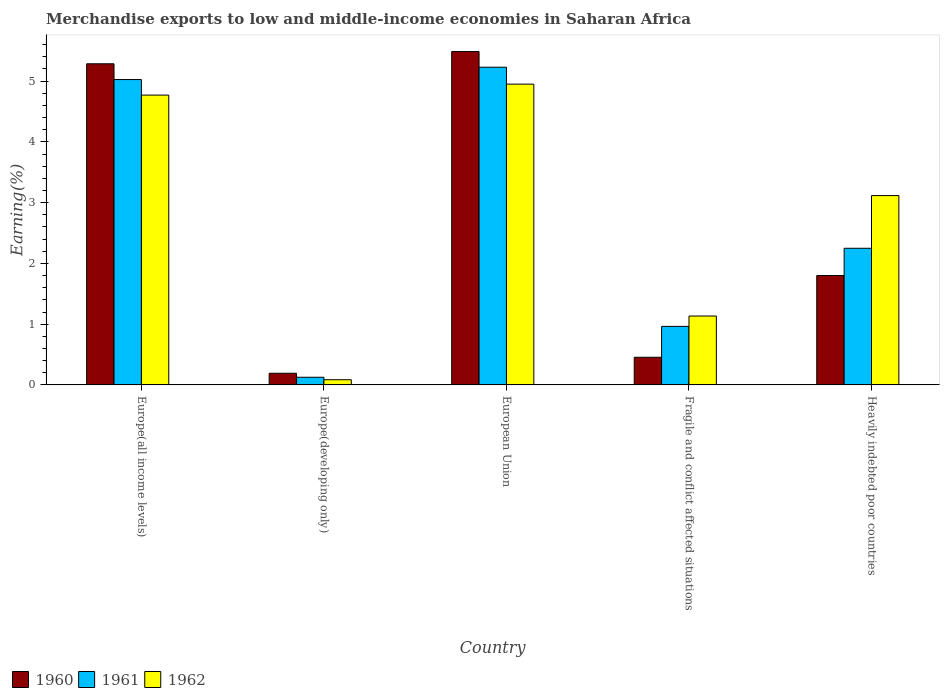How many different coloured bars are there?
Ensure brevity in your answer.  3. Are the number of bars on each tick of the X-axis equal?
Your response must be concise. Yes. How many bars are there on the 2nd tick from the left?
Offer a very short reply. 3. How many bars are there on the 3rd tick from the right?
Your answer should be very brief. 3. What is the label of the 1st group of bars from the left?
Make the answer very short. Europe(all income levels). In how many cases, is the number of bars for a given country not equal to the number of legend labels?
Your answer should be compact. 0. What is the percentage of amount earned from merchandise exports in 1962 in Heavily indebted poor countries?
Make the answer very short. 3.12. Across all countries, what is the maximum percentage of amount earned from merchandise exports in 1960?
Give a very brief answer. 5.49. Across all countries, what is the minimum percentage of amount earned from merchandise exports in 1962?
Give a very brief answer. 0.09. In which country was the percentage of amount earned from merchandise exports in 1961 maximum?
Make the answer very short. European Union. In which country was the percentage of amount earned from merchandise exports in 1961 minimum?
Keep it short and to the point. Europe(developing only). What is the total percentage of amount earned from merchandise exports in 1961 in the graph?
Give a very brief answer. 13.59. What is the difference between the percentage of amount earned from merchandise exports in 1960 in European Union and that in Heavily indebted poor countries?
Ensure brevity in your answer.  3.69. What is the difference between the percentage of amount earned from merchandise exports in 1960 in Europe(developing only) and the percentage of amount earned from merchandise exports in 1961 in Heavily indebted poor countries?
Ensure brevity in your answer.  -2.06. What is the average percentage of amount earned from merchandise exports in 1962 per country?
Your answer should be compact. 2.81. What is the difference between the percentage of amount earned from merchandise exports of/in 1961 and percentage of amount earned from merchandise exports of/in 1960 in European Union?
Your response must be concise. -0.26. What is the ratio of the percentage of amount earned from merchandise exports in 1961 in Europe(developing only) to that in European Union?
Ensure brevity in your answer.  0.02. Is the percentage of amount earned from merchandise exports in 1961 in Europe(developing only) less than that in Heavily indebted poor countries?
Offer a very short reply. Yes. What is the difference between the highest and the second highest percentage of amount earned from merchandise exports in 1962?
Give a very brief answer. -1.83. What is the difference between the highest and the lowest percentage of amount earned from merchandise exports in 1961?
Make the answer very short. 5.1. Is the sum of the percentage of amount earned from merchandise exports in 1962 in Fragile and conflict affected situations and Heavily indebted poor countries greater than the maximum percentage of amount earned from merchandise exports in 1960 across all countries?
Provide a succinct answer. No. Is it the case that in every country, the sum of the percentage of amount earned from merchandise exports in 1962 and percentage of amount earned from merchandise exports in 1960 is greater than the percentage of amount earned from merchandise exports in 1961?
Keep it short and to the point. Yes. How many bars are there?
Offer a very short reply. 15. Are all the bars in the graph horizontal?
Keep it short and to the point. No. Are the values on the major ticks of Y-axis written in scientific E-notation?
Offer a terse response. No. Does the graph contain grids?
Provide a short and direct response. No. How many legend labels are there?
Provide a short and direct response. 3. How are the legend labels stacked?
Your response must be concise. Horizontal. What is the title of the graph?
Make the answer very short. Merchandise exports to low and middle-income economies in Saharan Africa. What is the label or title of the X-axis?
Offer a very short reply. Country. What is the label or title of the Y-axis?
Offer a very short reply. Earning(%). What is the Earning(%) of 1960 in Europe(all income levels)?
Keep it short and to the point. 5.29. What is the Earning(%) of 1961 in Europe(all income levels)?
Make the answer very short. 5.03. What is the Earning(%) of 1962 in Europe(all income levels)?
Offer a terse response. 4.77. What is the Earning(%) in 1960 in Europe(developing only)?
Provide a succinct answer. 0.19. What is the Earning(%) of 1961 in Europe(developing only)?
Your response must be concise. 0.13. What is the Earning(%) in 1962 in Europe(developing only)?
Give a very brief answer. 0.09. What is the Earning(%) of 1960 in European Union?
Offer a terse response. 5.49. What is the Earning(%) in 1961 in European Union?
Your response must be concise. 5.23. What is the Earning(%) of 1962 in European Union?
Your answer should be compact. 4.95. What is the Earning(%) in 1960 in Fragile and conflict affected situations?
Your answer should be compact. 0.45. What is the Earning(%) in 1961 in Fragile and conflict affected situations?
Your answer should be compact. 0.96. What is the Earning(%) in 1962 in Fragile and conflict affected situations?
Your response must be concise. 1.13. What is the Earning(%) in 1960 in Heavily indebted poor countries?
Offer a terse response. 1.8. What is the Earning(%) in 1961 in Heavily indebted poor countries?
Provide a succinct answer. 2.25. What is the Earning(%) of 1962 in Heavily indebted poor countries?
Your response must be concise. 3.12. Across all countries, what is the maximum Earning(%) in 1960?
Offer a very short reply. 5.49. Across all countries, what is the maximum Earning(%) of 1961?
Offer a terse response. 5.23. Across all countries, what is the maximum Earning(%) of 1962?
Give a very brief answer. 4.95. Across all countries, what is the minimum Earning(%) of 1960?
Provide a succinct answer. 0.19. Across all countries, what is the minimum Earning(%) of 1961?
Provide a succinct answer. 0.13. Across all countries, what is the minimum Earning(%) of 1962?
Your response must be concise. 0.09. What is the total Earning(%) in 1960 in the graph?
Give a very brief answer. 13.22. What is the total Earning(%) of 1961 in the graph?
Offer a very short reply. 13.59. What is the total Earning(%) of 1962 in the graph?
Make the answer very short. 14.06. What is the difference between the Earning(%) in 1960 in Europe(all income levels) and that in Europe(developing only)?
Your response must be concise. 5.09. What is the difference between the Earning(%) of 1961 in Europe(all income levels) and that in Europe(developing only)?
Keep it short and to the point. 4.9. What is the difference between the Earning(%) in 1962 in Europe(all income levels) and that in Europe(developing only)?
Ensure brevity in your answer.  4.68. What is the difference between the Earning(%) of 1960 in Europe(all income levels) and that in European Union?
Provide a short and direct response. -0.2. What is the difference between the Earning(%) in 1961 in Europe(all income levels) and that in European Union?
Keep it short and to the point. -0.2. What is the difference between the Earning(%) in 1962 in Europe(all income levels) and that in European Union?
Make the answer very short. -0.18. What is the difference between the Earning(%) of 1960 in Europe(all income levels) and that in Fragile and conflict affected situations?
Keep it short and to the point. 4.83. What is the difference between the Earning(%) of 1961 in Europe(all income levels) and that in Fragile and conflict affected situations?
Give a very brief answer. 4.06. What is the difference between the Earning(%) of 1962 in Europe(all income levels) and that in Fragile and conflict affected situations?
Your answer should be very brief. 3.64. What is the difference between the Earning(%) of 1960 in Europe(all income levels) and that in Heavily indebted poor countries?
Your response must be concise. 3.48. What is the difference between the Earning(%) in 1961 in Europe(all income levels) and that in Heavily indebted poor countries?
Provide a succinct answer. 2.78. What is the difference between the Earning(%) in 1962 in Europe(all income levels) and that in Heavily indebted poor countries?
Ensure brevity in your answer.  1.65. What is the difference between the Earning(%) of 1960 in Europe(developing only) and that in European Union?
Your response must be concise. -5.29. What is the difference between the Earning(%) of 1961 in Europe(developing only) and that in European Union?
Give a very brief answer. -5.1. What is the difference between the Earning(%) in 1962 in Europe(developing only) and that in European Union?
Provide a succinct answer. -4.87. What is the difference between the Earning(%) of 1960 in Europe(developing only) and that in Fragile and conflict affected situations?
Your response must be concise. -0.26. What is the difference between the Earning(%) of 1961 in Europe(developing only) and that in Fragile and conflict affected situations?
Provide a short and direct response. -0.84. What is the difference between the Earning(%) in 1962 in Europe(developing only) and that in Fragile and conflict affected situations?
Ensure brevity in your answer.  -1.05. What is the difference between the Earning(%) of 1960 in Europe(developing only) and that in Heavily indebted poor countries?
Make the answer very short. -1.61. What is the difference between the Earning(%) in 1961 in Europe(developing only) and that in Heavily indebted poor countries?
Keep it short and to the point. -2.12. What is the difference between the Earning(%) in 1962 in Europe(developing only) and that in Heavily indebted poor countries?
Give a very brief answer. -3.03. What is the difference between the Earning(%) in 1960 in European Union and that in Fragile and conflict affected situations?
Make the answer very short. 5.03. What is the difference between the Earning(%) in 1961 in European Union and that in Fragile and conflict affected situations?
Offer a terse response. 4.27. What is the difference between the Earning(%) in 1962 in European Union and that in Fragile and conflict affected situations?
Your response must be concise. 3.82. What is the difference between the Earning(%) of 1960 in European Union and that in Heavily indebted poor countries?
Provide a short and direct response. 3.69. What is the difference between the Earning(%) of 1961 in European Union and that in Heavily indebted poor countries?
Ensure brevity in your answer.  2.98. What is the difference between the Earning(%) in 1962 in European Union and that in Heavily indebted poor countries?
Offer a very short reply. 1.83. What is the difference between the Earning(%) of 1960 in Fragile and conflict affected situations and that in Heavily indebted poor countries?
Offer a terse response. -1.35. What is the difference between the Earning(%) in 1961 in Fragile and conflict affected situations and that in Heavily indebted poor countries?
Make the answer very short. -1.29. What is the difference between the Earning(%) of 1962 in Fragile and conflict affected situations and that in Heavily indebted poor countries?
Provide a succinct answer. -1.98. What is the difference between the Earning(%) in 1960 in Europe(all income levels) and the Earning(%) in 1961 in Europe(developing only)?
Your answer should be very brief. 5.16. What is the difference between the Earning(%) of 1960 in Europe(all income levels) and the Earning(%) of 1962 in Europe(developing only)?
Offer a terse response. 5.2. What is the difference between the Earning(%) of 1961 in Europe(all income levels) and the Earning(%) of 1962 in Europe(developing only)?
Offer a terse response. 4.94. What is the difference between the Earning(%) of 1960 in Europe(all income levels) and the Earning(%) of 1961 in European Union?
Your answer should be very brief. 0.06. What is the difference between the Earning(%) in 1960 in Europe(all income levels) and the Earning(%) in 1962 in European Union?
Provide a short and direct response. 0.33. What is the difference between the Earning(%) of 1961 in Europe(all income levels) and the Earning(%) of 1962 in European Union?
Ensure brevity in your answer.  0.08. What is the difference between the Earning(%) of 1960 in Europe(all income levels) and the Earning(%) of 1961 in Fragile and conflict affected situations?
Your response must be concise. 4.32. What is the difference between the Earning(%) in 1960 in Europe(all income levels) and the Earning(%) in 1962 in Fragile and conflict affected situations?
Keep it short and to the point. 4.15. What is the difference between the Earning(%) in 1961 in Europe(all income levels) and the Earning(%) in 1962 in Fragile and conflict affected situations?
Your answer should be compact. 3.89. What is the difference between the Earning(%) in 1960 in Europe(all income levels) and the Earning(%) in 1961 in Heavily indebted poor countries?
Your response must be concise. 3.04. What is the difference between the Earning(%) of 1960 in Europe(all income levels) and the Earning(%) of 1962 in Heavily indebted poor countries?
Provide a succinct answer. 2.17. What is the difference between the Earning(%) in 1961 in Europe(all income levels) and the Earning(%) in 1962 in Heavily indebted poor countries?
Offer a very short reply. 1.91. What is the difference between the Earning(%) in 1960 in Europe(developing only) and the Earning(%) in 1961 in European Union?
Provide a short and direct response. -5.04. What is the difference between the Earning(%) in 1960 in Europe(developing only) and the Earning(%) in 1962 in European Union?
Provide a succinct answer. -4.76. What is the difference between the Earning(%) in 1961 in Europe(developing only) and the Earning(%) in 1962 in European Union?
Make the answer very short. -4.82. What is the difference between the Earning(%) in 1960 in Europe(developing only) and the Earning(%) in 1961 in Fragile and conflict affected situations?
Your response must be concise. -0.77. What is the difference between the Earning(%) of 1960 in Europe(developing only) and the Earning(%) of 1962 in Fragile and conflict affected situations?
Keep it short and to the point. -0.94. What is the difference between the Earning(%) in 1961 in Europe(developing only) and the Earning(%) in 1962 in Fragile and conflict affected situations?
Provide a succinct answer. -1.01. What is the difference between the Earning(%) in 1960 in Europe(developing only) and the Earning(%) in 1961 in Heavily indebted poor countries?
Offer a terse response. -2.06. What is the difference between the Earning(%) of 1960 in Europe(developing only) and the Earning(%) of 1962 in Heavily indebted poor countries?
Ensure brevity in your answer.  -2.92. What is the difference between the Earning(%) in 1961 in Europe(developing only) and the Earning(%) in 1962 in Heavily indebted poor countries?
Provide a succinct answer. -2.99. What is the difference between the Earning(%) in 1960 in European Union and the Earning(%) in 1961 in Fragile and conflict affected situations?
Provide a succinct answer. 4.52. What is the difference between the Earning(%) in 1960 in European Union and the Earning(%) in 1962 in Fragile and conflict affected situations?
Give a very brief answer. 4.35. What is the difference between the Earning(%) of 1961 in European Union and the Earning(%) of 1962 in Fragile and conflict affected situations?
Offer a very short reply. 4.1. What is the difference between the Earning(%) of 1960 in European Union and the Earning(%) of 1961 in Heavily indebted poor countries?
Keep it short and to the point. 3.24. What is the difference between the Earning(%) in 1960 in European Union and the Earning(%) in 1962 in Heavily indebted poor countries?
Make the answer very short. 2.37. What is the difference between the Earning(%) in 1961 in European Union and the Earning(%) in 1962 in Heavily indebted poor countries?
Ensure brevity in your answer.  2.11. What is the difference between the Earning(%) of 1960 in Fragile and conflict affected situations and the Earning(%) of 1961 in Heavily indebted poor countries?
Make the answer very short. -1.79. What is the difference between the Earning(%) of 1960 in Fragile and conflict affected situations and the Earning(%) of 1962 in Heavily indebted poor countries?
Offer a very short reply. -2.66. What is the difference between the Earning(%) in 1961 in Fragile and conflict affected situations and the Earning(%) in 1962 in Heavily indebted poor countries?
Give a very brief answer. -2.15. What is the average Earning(%) in 1960 per country?
Make the answer very short. 2.64. What is the average Earning(%) in 1961 per country?
Give a very brief answer. 2.72. What is the average Earning(%) of 1962 per country?
Offer a very short reply. 2.81. What is the difference between the Earning(%) of 1960 and Earning(%) of 1961 in Europe(all income levels)?
Your response must be concise. 0.26. What is the difference between the Earning(%) in 1960 and Earning(%) in 1962 in Europe(all income levels)?
Offer a terse response. 0.52. What is the difference between the Earning(%) of 1961 and Earning(%) of 1962 in Europe(all income levels)?
Offer a very short reply. 0.26. What is the difference between the Earning(%) in 1960 and Earning(%) in 1961 in Europe(developing only)?
Ensure brevity in your answer.  0.07. What is the difference between the Earning(%) in 1960 and Earning(%) in 1962 in Europe(developing only)?
Your answer should be very brief. 0.11. What is the difference between the Earning(%) in 1961 and Earning(%) in 1962 in Europe(developing only)?
Make the answer very short. 0.04. What is the difference between the Earning(%) in 1960 and Earning(%) in 1961 in European Union?
Make the answer very short. 0.26. What is the difference between the Earning(%) of 1960 and Earning(%) of 1962 in European Union?
Keep it short and to the point. 0.54. What is the difference between the Earning(%) of 1961 and Earning(%) of 1962 in European Union?
Keep it short and to the point. 0.28. What is the difference between the Earning(%) in 1960 and Earning(%) in 1961 in Fragile and conflict affected situations?
Keep it short and to the point. -0.51. What is the difference between the Earning(%) of 1960 and Earning(%) of 1962 in Fragile and conflict affected situations?
Offer a terse response. -0.68. What is the difference between the Earning(%) of 1961 and Earning(%) of 1962 in Fragile and conflict affected situations?
Provide a short and direct response. -0.17. What is the difference between the Earning(%) in 1960 and Earning(%) in 1961 in Heavily indebted poor countries?
Make the answer very short. -0.45. What is the difference between the Earning(%) of 1960 and Earning(%) of 1962 in Heavily indebted poor countries?
Make the answer very short. -1.32. What is the difference between the Earning(%) of 1961 and Earning(%) of 1962 in Heavily indebted poor countries?
Offer a very short reply. -0.87. What is the ratio of the Earning(%) of 1960 in Europe(all income levels) to that in Europe(developing only)?
Offer a very short reply. 27.54. What is the ratio of the Earning(%) of 1961 in Europe(all income levels) to that in Europe(developing only)?
Ensure brevity in your answer.  39.9. What is the ratio of the Earning(%) in 1962 in Europe(all income levels) to that in Europe(developing only)?
Ensure brevity in your answer.  55.85. What is the ratio of the Earning(%) in 1960 in Europe(all income levels) to that in European Union?
Ensure brevity in your answer.  0.96. What is the ratio of the Earning(%) in 1961 in Europe(all income levels) to that in European Union?
Make the answer very short. 0.96. What is the ratio of the Earning(%) of 1962 in Europe(all income levels) to that in European Union?
Provide a short and direct response. 0.96. What is the ratio of the Earning(%) in 1960 in Europe(all income levels) to that in Fragile and conflict affected situations?
Make the answer very short. 11.62. What is the ratio of the Earning(%) in 1961 in Europe(all income levels) to that in Fragile and conflict affected situations?
Make the answer very short. 5.22. What is the ratio of the Earning(%) in 1962 in Europe(all income levels) to that in Fragile and conflict affected situations?
Ensure brevity in your answer.  4.21. What is the ratio of the Earning(%) of 1960 in Europe(all income levels) to that in Heavily indebted poor countries?
Offer a very short reply. 2.94. What is the ratio of the Earning(%) of 1961 in Europe(all income levels) to that in Heavily indebted poor countries?
Give a very brief answer. 2.23. What is the ratio of the Earning(%) of 1962 in Europe(all income levels) to that in Heavily indebted poor countries?
Make the answer very short. 1.53. What is the ratio of the Earning(%) in 1960 in Europe(developing only) to that in European Union?
Offer a very short reply. 0.04. What is the ratio of the Earning(%) in 1961 in Europe(developing only) to that in European Union?
Your answer should be very brief. 0.02. What is the ratio of the Earning(%) in 1962 in Europe(developing only) to that in European Union?
Give a very brief answer. 0.02. What is the ratio of the Earning(%) of 1960 in Europe(developing only) to that in Fragile and conflict affected situations?
Offer a very short reply. 0.42. What is the ratio of the Earning(%) in 1961 in Europe(developing only) to that in Fragile and conflict affected situations?
Give a very brief answer. 0.13. What is the ratio of the Earning(%) in 1962 in Europe(developing only) to that in Fragile and conflict affected situations?
Make the answer very short. 0.08. What is the ratio of the Earning(%) of 1960 in Europe(developing only) to that in Heavily indebted poor countries?
Keep it short and to the point. 0.11. What is the ratio of the Earning(%) in 1961 in Europe(developing only) to that in Heavily indebted poor countries?
Provide a succinct answer. 0.06. What is the ratio of the Earning(%) in 1962 in Europe(developing only) to that in Heavily indebted poor countries?
Your answer should be very brief. 0.03. What is the ratio of the Earning(%) of 1960 in European Union to that in Fragile and conflict affected situations?
Provide a succinct answer. 12.06. What is the ratio of the Earning(%) in 1961 in European Union to that in Fragile and conflict affected situations?
Keep it short and to the point. 5.43. What is the ratio of the Earning(%) of 1962 in European Union to that in Fragile and conflict affected situations?
Offer a terse response. 4.37. What is the ratio of the Earning(%) of 1960 in European Union to that in Heavily indebted poor countries?
Provide a succinct answer. 3.05. What is the ratio of the Earning(%) in 1961 in European Union to that in Heavily indebted poor countries?
Provide a short and direct response. 2.33. What is the ratio of the Earning(%) of 1962 in European Union to that in Heavily indebted poor countries?
Your answer should be very brief. 1.59. What is the ratio of the Earning(%) of 1960 in Fragile and conflict affected situations to that in Heavily indebted poor countries?
Your answer should be very brief. 0.25. What is the ratio of the Earning(%) in 1961 in Fragile and conflict affected situations to that in Heavily indebted poor countries?
Make the answer very short. 0.43. What is the ratio of the Earning(%) of 1962 in Fragile and conflict affected situations to that in Heavily indebted poor countries?
Your response must be concise. 0.36. What is the difference between the highest and the second highest Earning(%) in 1960?
Offer a terse response. 0.2. What is the difference between the highest and the second highest Earning(%) in 1961?
Give a very brief answer. 0.2. What is the difference between the highest and the second highest Earning(%) of 1962?
Offer a very short reply. 0.18. What is the difference between the highest and the lowest Earning(%) in 1960?
Offer a terse response. 5.29. What is the difference between the highest and the lowest Earning(%) of 1961?
Provide a succinct answer. 5.1. What is the difference between the highest and the lowest Earning(%) in 1962?
Your answer should be very brief. 4.87. 